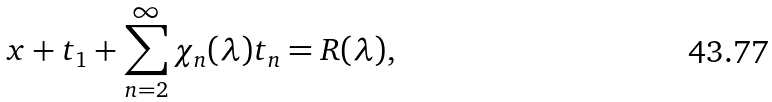Convert formula to latex. <formula><loc_0><loc_0><loc_500><loc_500>x + t _ { 1 } + \sum _ { n = 2 } ^ { \infty } \chi _ { n } ( \lambda ) t _ { n } = R ( \lambda ) ,</formula> 